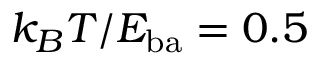<formula> <loc_0><loc_0><loc_500><loc_500>k _ { B } T / E _ { b a } = 0 . 5</formula> 